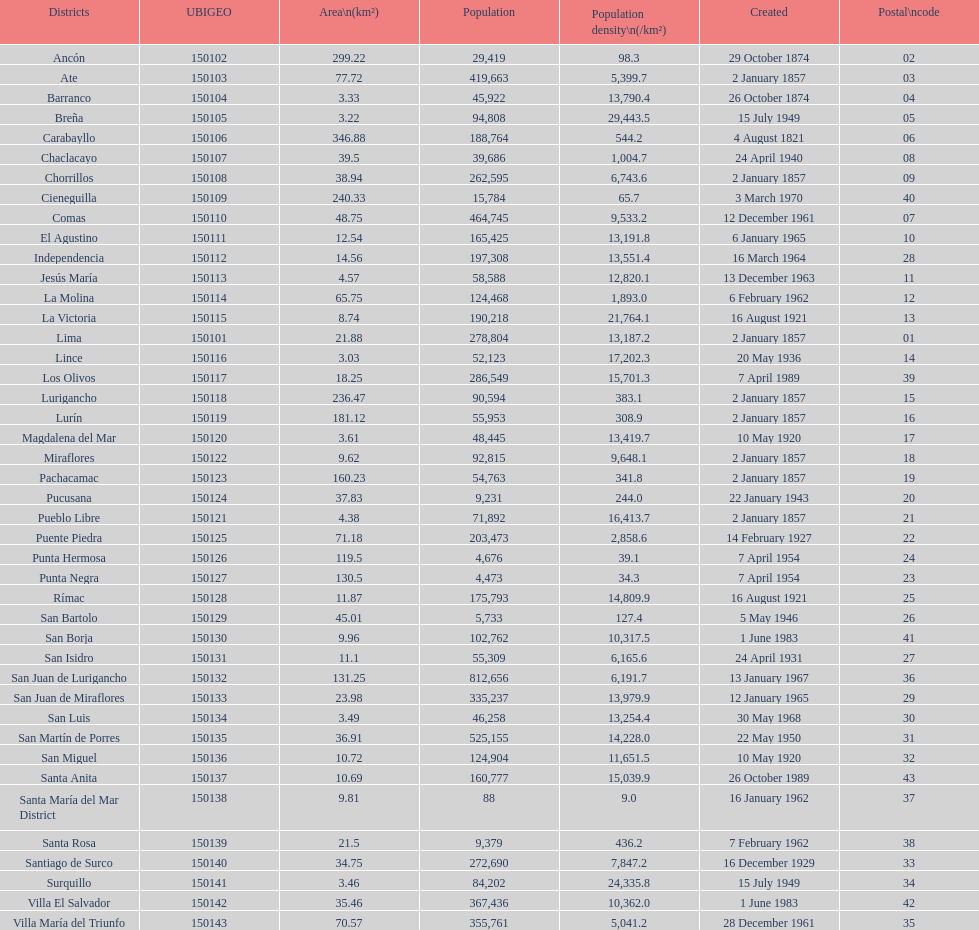What is the number of districts in this city? 43. 